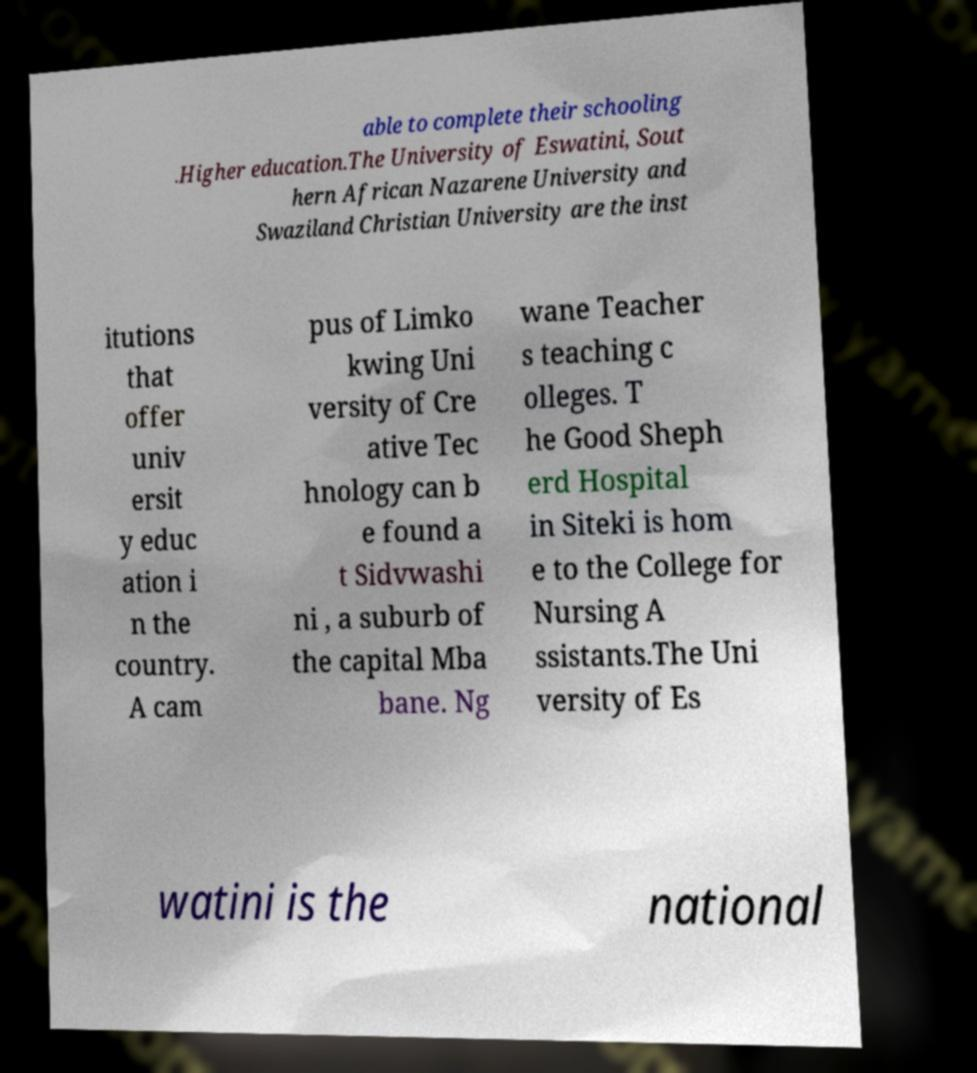For documentation purposes, I need the text within this image transcribed. Could you provide that? able to complete their schooling .Higher education.The University of Eswatini, Sout hern African Nazarene University and Swaziland Christian University are the inst itutions that offer univ ersit y educ ation i n the country. A cam pus of Limko kwing Uni versity of Cre ative Tec hnology can b e found a t Sidvwashi ni , a suburb of the capital Mba bane. Ng wane Teacher s teaching c olleges. T he Good Sheph erd Hospital in Siteki is hom e to the College for Nursing A ssistants.The Uni versity of Es watini is the national 